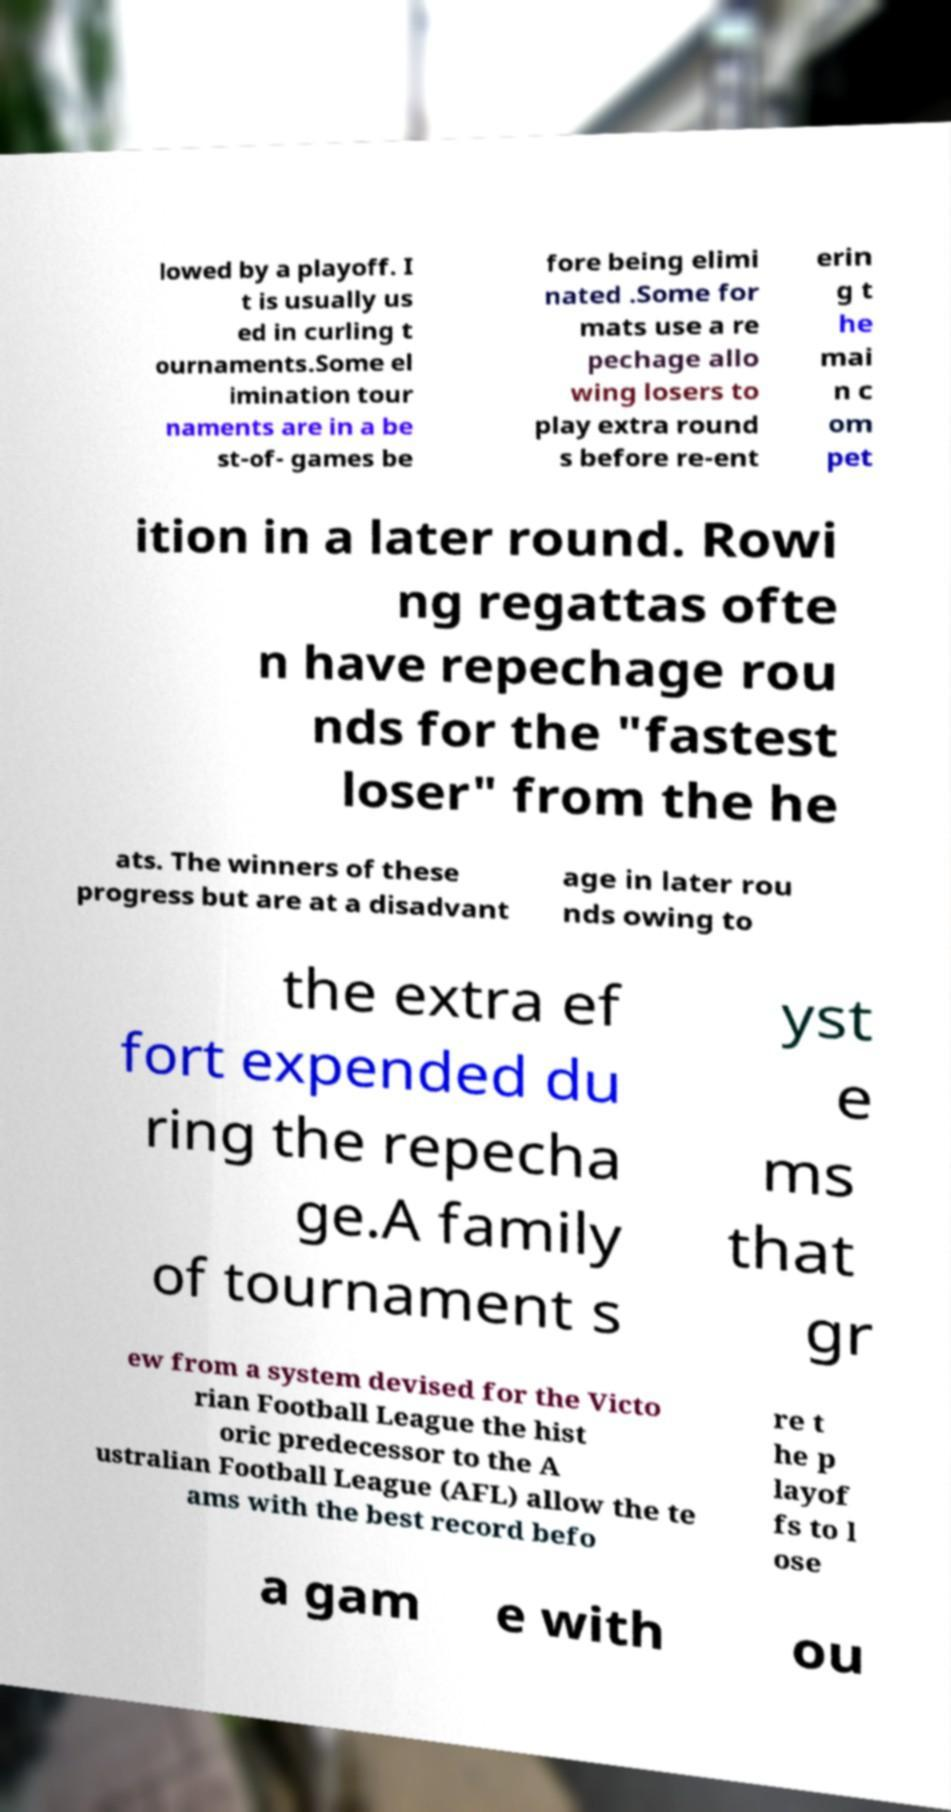Could you assist in decoding the text presented in this image and type it out clearly? lowed by a playoff. I t is usually us ed in curling t ournaments.Some el imination tour naments are in a be st-of- games be fore being elimi nated .Some for mats use a re pechage allo wing losers to play extra round s before re-ent erin g t he mai n c om pet ition in a later round. Rowi ng regattas ofte n have repechage rou nds for the "fastest loser" from the he ats. The winners of these progress but are at a disadvant age in later rou nds owing to the extra ef fort expended du ring the repecha ge.A family of tournament s yst e ms that gr ew from a system devised for the Victo rian Football League the hist oric predecessor to the A ustralian Football League (AFL) allow the te ams with the best record befo re t he p layof fs to l ose a gam e with ou 